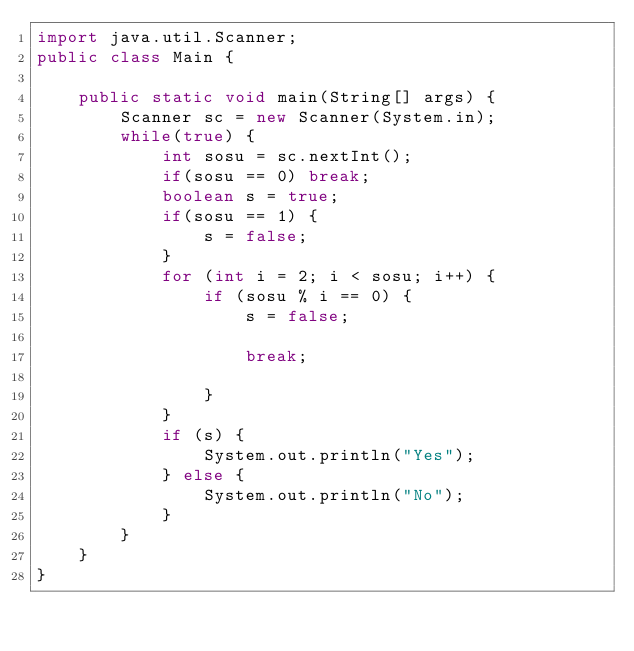<code> <loc_0><loc_0><loc_500><loc_500><_Java_>import java.util.Scanner;
public class Main {

    public static void main(String[] args) {
        Scanner sc = new Scanner(System.in);
        while(true) {
            int sosu = sc.nextInt();
            if(sosu == 0) break;
            boolean s = true;
            if(sosu == 1) {
                s = false;
            }
            for (int i = 2; i < sosu; i++) {
                if (sosu % i == 0) {
                    s = false;

                    break;

                }
            }
            if (s) {
                System.out.println("Yes");
            } else {
                System.out.println("No");
            }
        }
    }
}</code> 